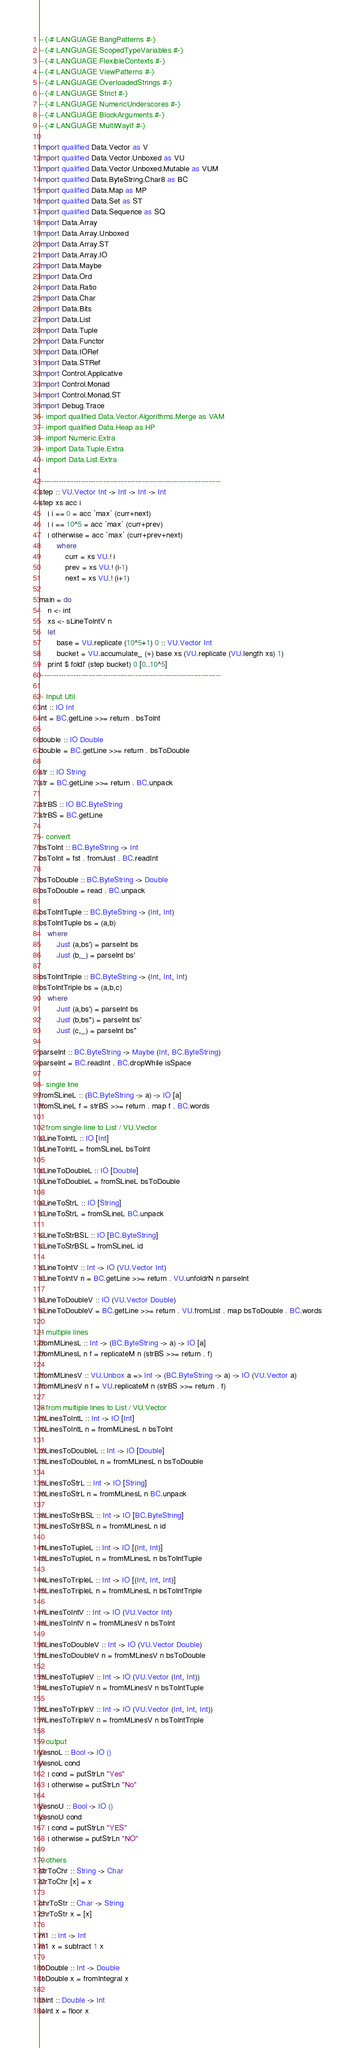<code> <loc_0><loc_0><loc_500><loc_500><_Haskell_>--{-# LANGUAGE BangPatterns #-}
--{-# LANGUAGE ScopedTypeVariables #-}
--{-# LANGUAGE FlexibleContexts #-}
--{-# LANGUAGE ViewPatterns #-}
--{-# LANGUAGE OverloadedStrings #-}
--{-# LANGUAGE Strict #-}
--{-# LANGUAGE NumericUnderscores #-}
--{-# LANGUAGE BlockArguments #-}
--{-# LANGUAGE MultiWayIf #-}

import qualified Data.Vector as V
import qualified Data.Vector.Unboxed as VU
import qualified Data.Vector.Unboxed.Mutable as VUM
import qualified Data.ByteString.Char8 as BC
import qualified Data.Map as MP
import qualified Data.Set as ST
import qualified Data.Sequence as SQ
import Data.Array
import Data.Array.Unboxed
import Data.Array.ST
import Data.Array.IO
import Data.Maybe
import Data.Ord
import Data.Ratio
import Data.Char
import Data.Bits
import Data.List
import Data.Tuple
import Data.Functor
import Data.IORef
import Data.STRef
import Control.Applicative
import Control.Monad
import Control.Monad.ST
import Debug.Trace
-- import qualified Data.Vector.Algorithms.Merge as VAM
-- import qualified Data.Heap as HP
-- import Numeric.Extra
-- import Data.Tuple.Extra
-- import Data.List.Extra

--------------------------------------------------------------------------
step :: VU.Vector Int -> Int -> Int -> Int
step xs acc i 
    | i == 0 = acc `max` (curr+next)
    | i == 10^5 = acc `max` (curr+prev)
    | otherwise = acc `max` (curr+prev+next)
        where
            curr = xs VU.! i
            prev = xs VU.! (i-1)
            next = xs VU.! (i+1)

main = do
    n <- int
    xs <- sLineToIntV n
    let
        base = VU.replicate (10^5+1) 0 :: VU.Vector Int
        bucket = VU.accumulate_ (+) base xs (VU.replicate (VU.length xs) 1)
    print $ foldl' (step bucket) 0 [0..10^5]
--------------------------------------------------------------------------

-- Input Util
int :: IO Int
int = BC.getLine >>= return . bsToInt

double :: IO Double
double = BC.getLine >>= return . bsToDouble

str :: IO String
str = BC.getLine >>= return . BC.unpack

strBS :: IO BC.ByteString
strBS = BC.getLine

-- convert
bsToInt :: BC.ByteString -> Int
bsToInt = fst . fromJust . BC.readInt

bsToDouble :: BC.ByteString -> Double
bsToDouble = read . BC.unpack

bsToIntTuple :: BC.ByteString -> (Int, Int)
bsToIntTuple bs = (a,b)
    where
        Just (a,bs') = parseInt bs
        Just (b,_) = parseInt bs'

bsToIntTriple :: BC.ByteString -> (Int, Int, Int)
bsToIntTriple bs = (a,b,c)
    where
        Just (a,bs') = parseInt bs
        Just (b,bs'') = parseInt bs'
        Just (c,_) = parseInt bs''

parseInt :: BC.ByteString -> Maybe (Int, BC.ByteString)
parseInt = BC.readInt . BC.dropWhile isSpace

-- single line
fromSLineL :: (BC.ByteString -> a) -> IO [a]
fromSLineL f = strBS >>= return . map f . BC.words

-- from single line to List / VU.Vector 
sLineToIntL :: IO [Int]
sLineToIntL = fromSLineL bsToInt

sLineToDoubleL :: IO [Double]
sLineToDoubleL = fromSLineL bsToDouble

sLineToStrL :: IO [String]
sLineToStrL = fromSLineL BC.unpack

sLineToStrBSL :: IO [BC.ByteString]
sLineToStrBSL = fromSLineL id 

sLineToIntV :: Int -> IO (VU.Vector Int)
sLineToIntV n = BC.getLine >>= return . VU.unfoldrN n parseInt

sLineToDoubleV :: IO (VU.Vector Double)
sLineToDoubleV = BC.getLine >>= return . VU.fromList . map bsToDouble . BC.words

-- multiple lines
fromMLinesL :: Int -> (BC.ByteString -> a) -> IO [a]
fromMLinesL n f = replicateM n (strBS >>= return . f)

fromMLinesV :: VU.Unbox a => Int -> (BC.ByteString -> a) -> IO (VU.Vector a)
fromMLinesV n f = VU.replicateM n (strBS >>= return . f)

-- from multiple lines to List / VU.Vector
mLinesToIntL :: Int -> IO [Int]
mLinesToIntL n = fromMLinesL n bsToInt

mLinesToDoubleL :: Int -> IO [Double]
mLinesToDoubleL n = fromMLinesL n bsToDouble

mLinesToStrL :: Int -> IO [String]
mLinesToStrL n = fromMLinesL n BC.unpack

mLinesToStrBSL :: Int -> IO [BC.ByteString]
mLinesToStrBSL n = fromMLinesL n id

mLinesToTupleL :: Int -> IO [(Int, Int)]
mLinesToTupleL n = fromMLinesL n bsToIntTuple

mLinesToTripleL :: Int -> IO [(Int, Int, Int)]
mLinesToTripleL n = fromMLinesL n bsToIntTriple

mLinesToIntV :: Int -> IO (VU.Vector Int)
mLinesToIntV n = fromMLinesV n bsToInt

mLinesToDoubleV :: Int -> IO (VU.Vector Double)
mLinesToDoubleV n = fromMLinesV n bsToDouble

mLinesToTupleV :: Int -> IO (VU.Vector (Int, Int))
mLinesToTupleV n = fromMLinesV n bsToIntTuple
    
mLinesToTripleV :: Int -> IO (VU.Vector (Int, Int, Int))
mLinesToTripleV n = fromMLinesV n bsToIntTriple

-- output
yesnoL :: Bool -> IO ()
yesnoL cond
    | cond = putStrLn "Yes"
    | otherwise = putStrLn "No"

yesnoU :: Bool -> IO ()
yesnoU cond
    | cond = putStrLn "YES"
    | otherwise = putStrLn "NO"

-- others
strToChr :: String -> Char
strToChr [x] = x

chrToStr :: Char -> String
chrToStr x = [x]

m1 :: Int -> Int
m1 x = subtract 1 x

toDouble :: Int -> Double
toDouble x = fromIntegral x

toInt :: Double -> Int
toInt x = floor x</code> 